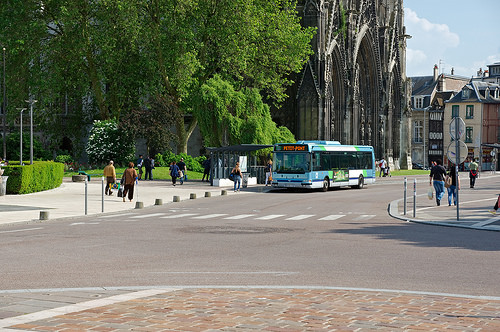<image>
Is the bus in the person? No. The bus is not contained within the person. These objects have a different spatial relationship. 